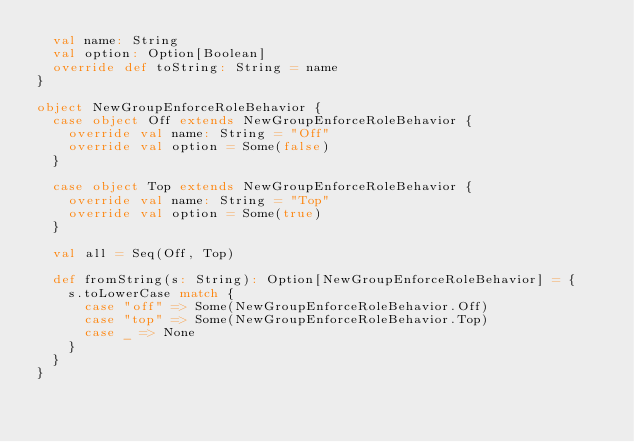<code> <loc_0><loc_0><loc_500><loc_500><_Scala_>  val name: String
  val option: Option[Boolean]
  override def toString: String = name
}

object NewGroupEnforceRoleBehavior {
  case object Off extends NewGroupEnforceRoleBehavior {
    override val name: String = "Off"
    override val option = Some(false)
  }

  case object Top extends NewGroupEnforceRoleBehavior {
    override val name: String = "Top"
    override val option = Some(true)
  }

  val all = Seq(Off, Top)

  def fromString(s: String): Option[NewGroupEnforceRoleBehavior] = {
    s.toLowerCase match {
      case "off" => Some(NewGroupEnforceRoleBehavior.Off)
      case "top" => Some(NewGroupEnforceRoleBehavior.Top)
      case _ => None
    }
  }
}
</code> 